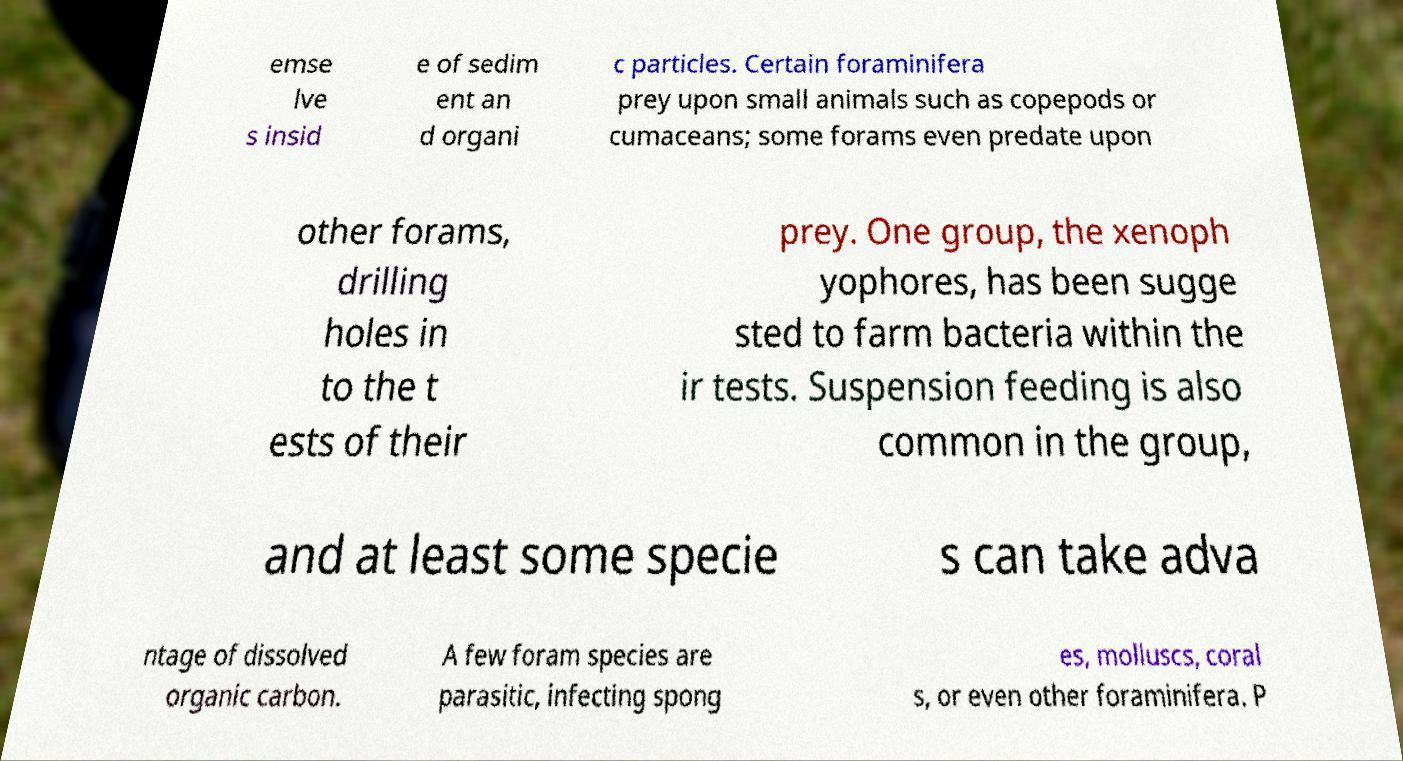What messages or text are displayed in this image? I need them in a readable, typed format. emse lve s insid e of sedim ent an d organi c particles. Certain foraminifera prey upon small animals such as copepods or cumaceans; some forams even predate upon other forams, drilling holes in to the t ests of their prey. One group, the xenoph yophores, has been sugge sted to farm bacteria within the ir tests. Suspension feeding is also common in the group, and at least some specie s can take adva ntage of dissolved organic carbon. A few foram species are parasitic, infecting spong es, molluscs, coral s, or even other foraminifera. P 